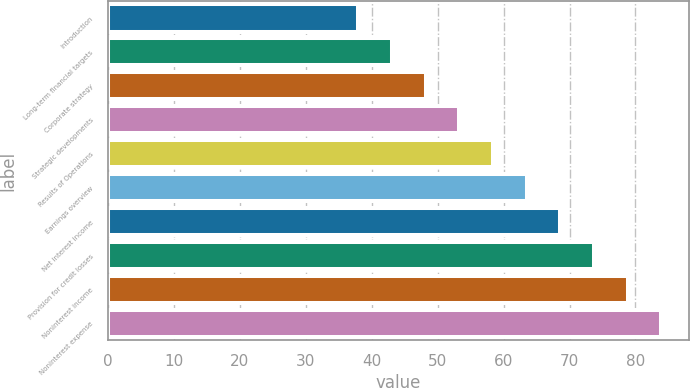<chart> <loc_0><loc_0><loc_500><loc_500><bar_chart><fcel>Introduction<fcel>Long-term financial targets<fcel>Corporate strategy<fcel>Strategic developments<fcel>Results of Operations<fcel>Earnings overview<fcel>Net interest income<fcel>Provision for credit losses<fcel>Noninterest income<fcel>Noninterest expense<nl><fcel>38<fcel>43.1<fcel>48.2<fcel>53.3<fcel>58.4<fcel>63.5<fcel>68.6<fcel>73.7<fcel>78.8<fcel>83.9<nl></chart> 